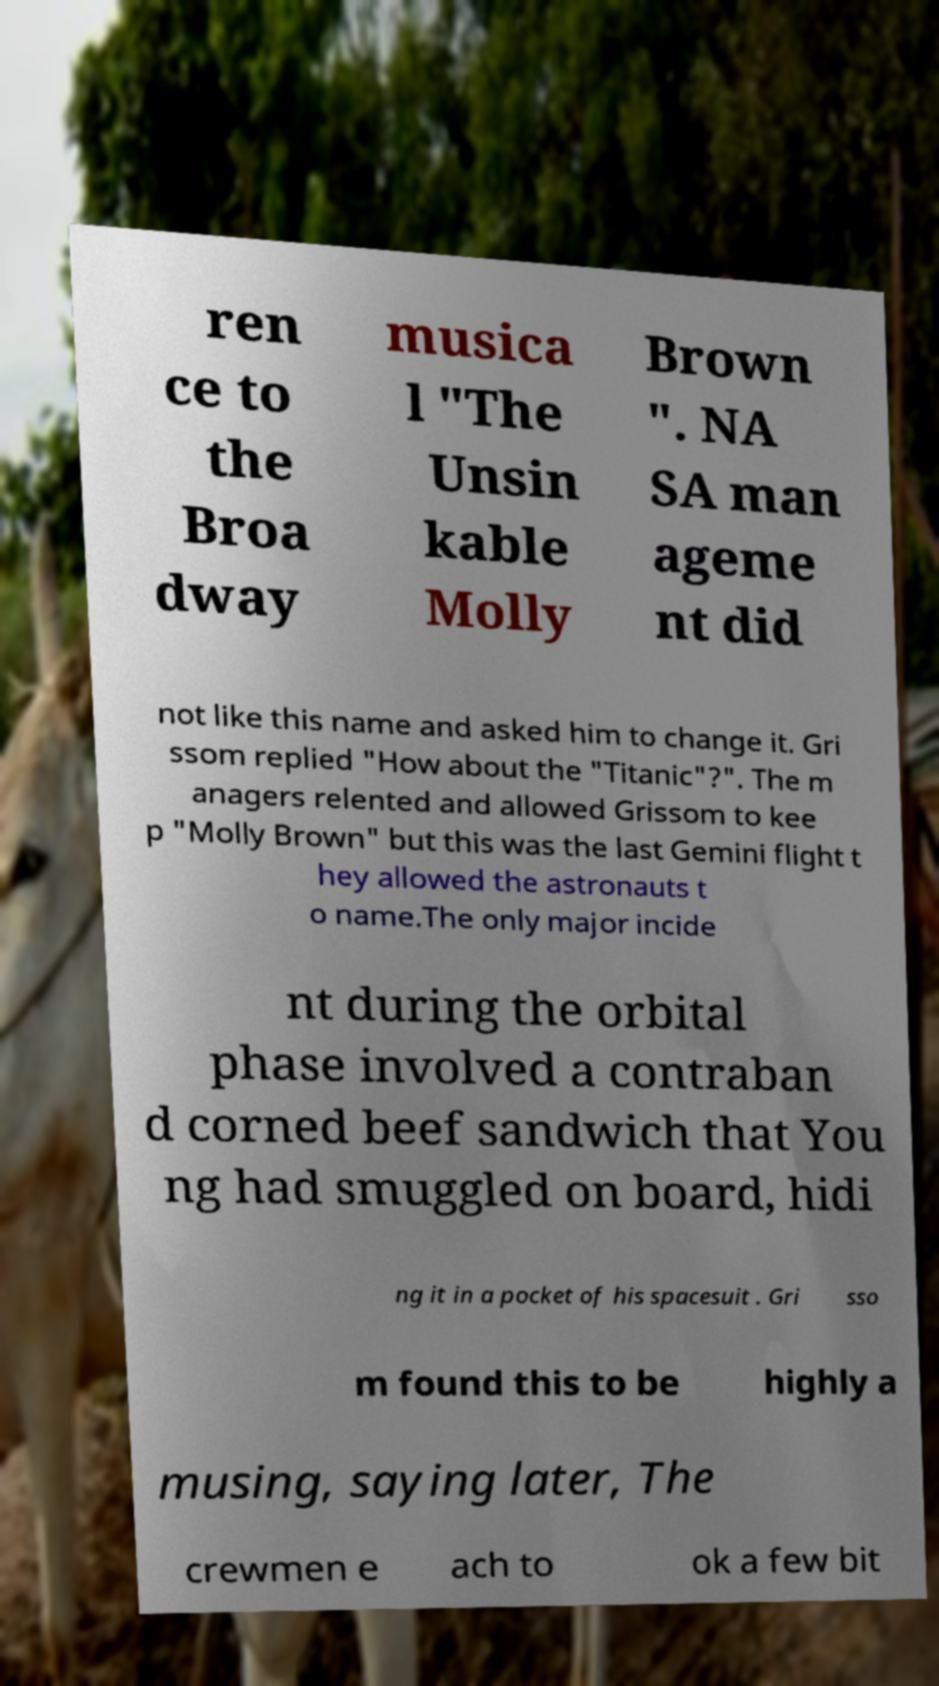Can you read and provide the text displayed in the image?This photo seems to have some interesting text. Can you extract and type it out for me? ren ce to the Broa dway musica l "The Unsin kable Molly Brown ". NA SA man ageme nt did not like this name and asked him to change it. Gri ssom replied "How about the "Titanic"?". The m anagers relented and allowed Grissom to kee p "Molly Brown" but this was the last Gemini flight t hey allowed the astronauts t o name.The only major incide nt during the orbital phase involved a contraban d corned beef sandwich that You ng had smuggled on board, hidi ng it in a pocket of his spacesuit . Gri sso m found this to be highly a musing, saying later, The crewmen e ach to ok a few bit 